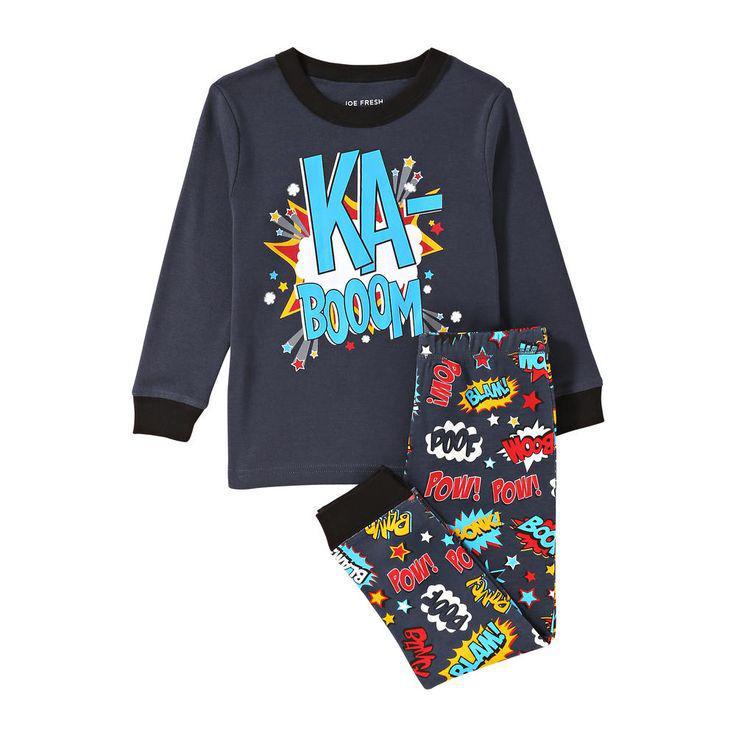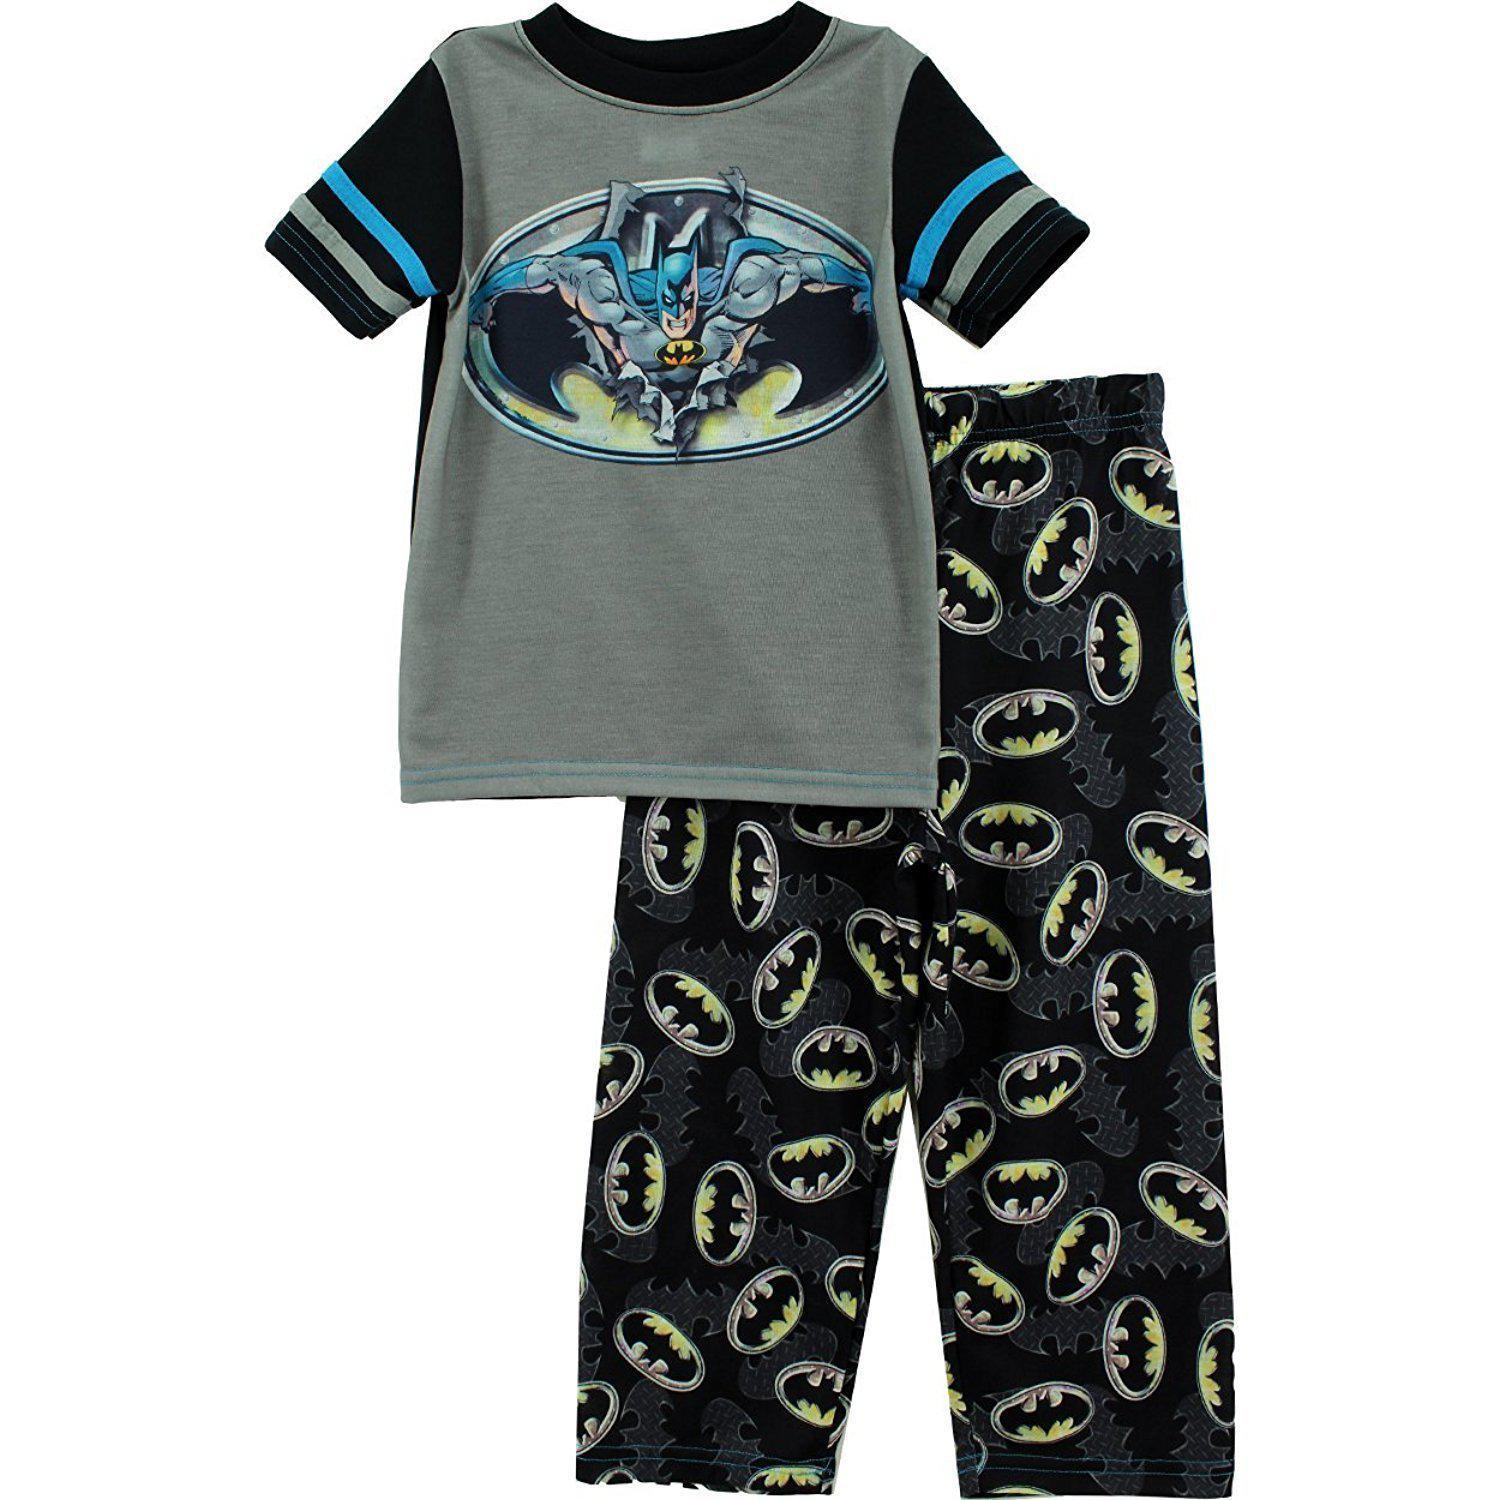The first image is the image on the left, the second image is the image on the right. For the images displayed, is the sentence "All the pajamas have long sleeves with small cuffs." factually correct? Answer yes or no. No. The first image is the image on the left, the second image is the image on the right. For the images shown, is this caption "At least one of the outfits has a brightly colored collar and brightly colored cuffs around the sleeves or ankles." true? Answer yes or no. No. 